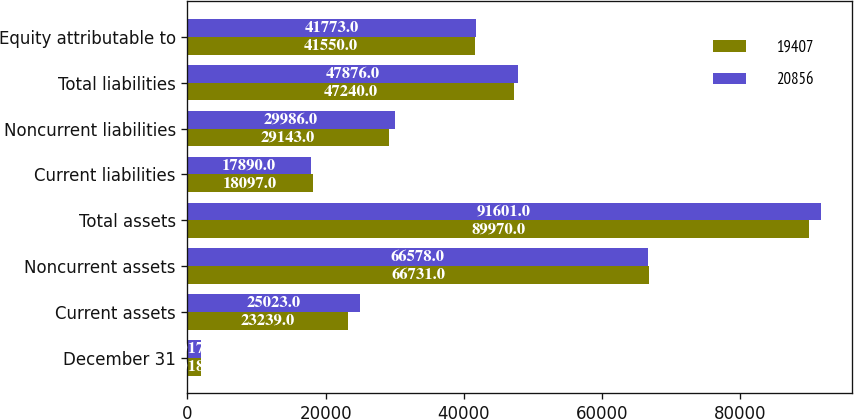<chart> <loc_0><loc_0><loc_500><loc_500><stacked_bar_chart><ecel><fcel>December 31<fcel>Current assets<fcel>Noncurrent assets<fcel>Total assets<fcel>Current liabilities<fcel>Noncurrent liabilities<fcel>Total liabilities<fcel>Equity attributable to<nl><fcel>19407<fcel>2018<fcel>23239<fcel>66731<fcel>89970<fcel>18097<fcel>29143<fcel>47240<fcel>41550<nl><fcel>20856<fcel>2017<fcel>25023<fcel>66578<fcel>91601<fcel>17890<fcel>29986<fcel>47876<fcel>41773<nl></chart> 